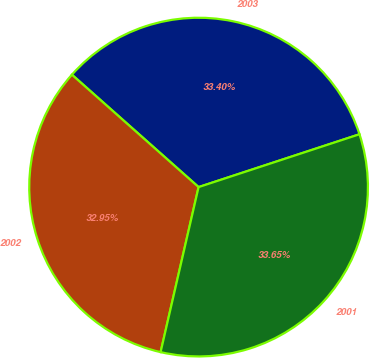<chart> <loc_0><loc_0><loc_500><loc_500><pie_chart><fcel>2003<fcel>2002<fcel>2001<nl><fcel>33.4%<fcel>32.95%<fcel>33.65%<nl></chart> 